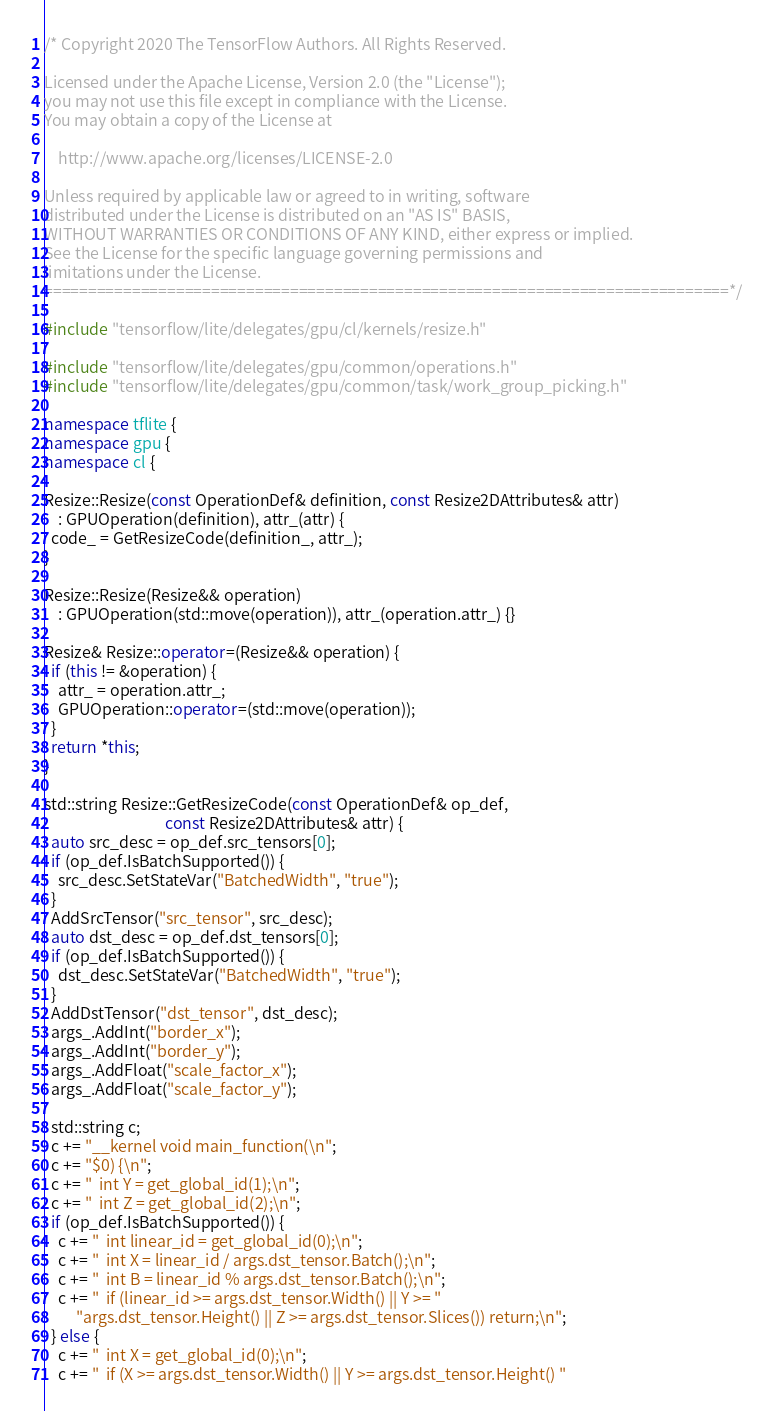Convert code to text. <code><loc_0><loc_0><loc_500><loc_500><_C++_>/* Copyright 2020 The TensorFlow Authors. All Rights Reserved.

Licensed under the Apache License, Version 2.0 (the "License");
you may not use this file except in compliance with the License.
You may obtain a copy of the License at

    http://www.apache.org/licenses/LICENSE-2.0

Unless required by applicable law or agreed to in writing, software
distributed under the License is distributed on an "AS IS" BASIS,
WITHOUT WARRANTIES OR CONDITIONS OF ANY KIND, either express or implied.
See the License for the specific language governing permissions and
limitations under the License.
==============================================================================*/

#include "tensorflow/lite/delegates/gpu/cl/kernels/resize.h"

#include "tensorflow/lite/delegates/gpu/common/operations.h"
#include "tensorflow/lite/delegates/gpu/common/task/work_group_picking.h"

namespace tflite {
namespace gpu {
namespace cl {

Resize::Resize(const OperationDef& definition, const Resize2DAttributes& attr)
    : GPUOperation(definition), attr_(attr) {
  code_ = GetResizeCode(definition_, attr_);
}

Resize::Resize(Resize&& operation)
    : GPUOperation(std::move(operation)), attr_(operation.attr_) {}

Resize& Resize::operator=(Resize&& operation) {
  if (this != &operation) {
    attr_ = operation.attr_;
    GPUOperation::operator=(std::move(operation));
  }
  return *this;
}

std::string Resize::GetResizeCode(const OperationDef& op_def,
                                  const Resize2DAttributes& attr) {
  auto src_desc = op_def.src_tensors[0];
  if (op_def.IsBatchSupported()) {
    src_desc.SetStateVar("BatchedWidth", "true");
  }
  AddSrcTensor("src_tensor", src_desc);
  auto dst_desc = op_def.dst_tensors[0];
  if (op_def.IsBatchSupported()) {
    dst_desc.SetStateVar("BatchedWidth", "true");
  }
  AddDstTensor("dst_tensor", dst_desc);
  args_.AddInt("border_x");
  args_.AddInt("border_y");
  args_.AddFloat("scale_factor_x");
  args_.AddFloat("scale_factor_y");

  std::string c;
  c += "__kernel void main_function(\n";
  c += "$0) {\n";
  c += "  int Y = get_global_id(1);\n";
  c += "  int Z = get_global_id(2);\n";
  if (op_def.IsBatchSupported()) {
    c += "  int linear_id = get_global_id(0);\n";
    c += "  int X = linear_id / args.dst_tensor.Batch();\n";
    c += "  int B = linear_id % args.dst_tensor.Batch();\n";
    c += "  if (linear_id >= args.dst_tensor.Width() || Y >= "
         "args.dst_tensor.Height() || Z >= args.dst_tensor.Slices()) return;\n";
  } else {
    c += "  int X = get_global_id(0);\n";
    c += "  if (X >= args.dst_tensor.Width() || Y >= args.dst_tensor.Height() "</code> 